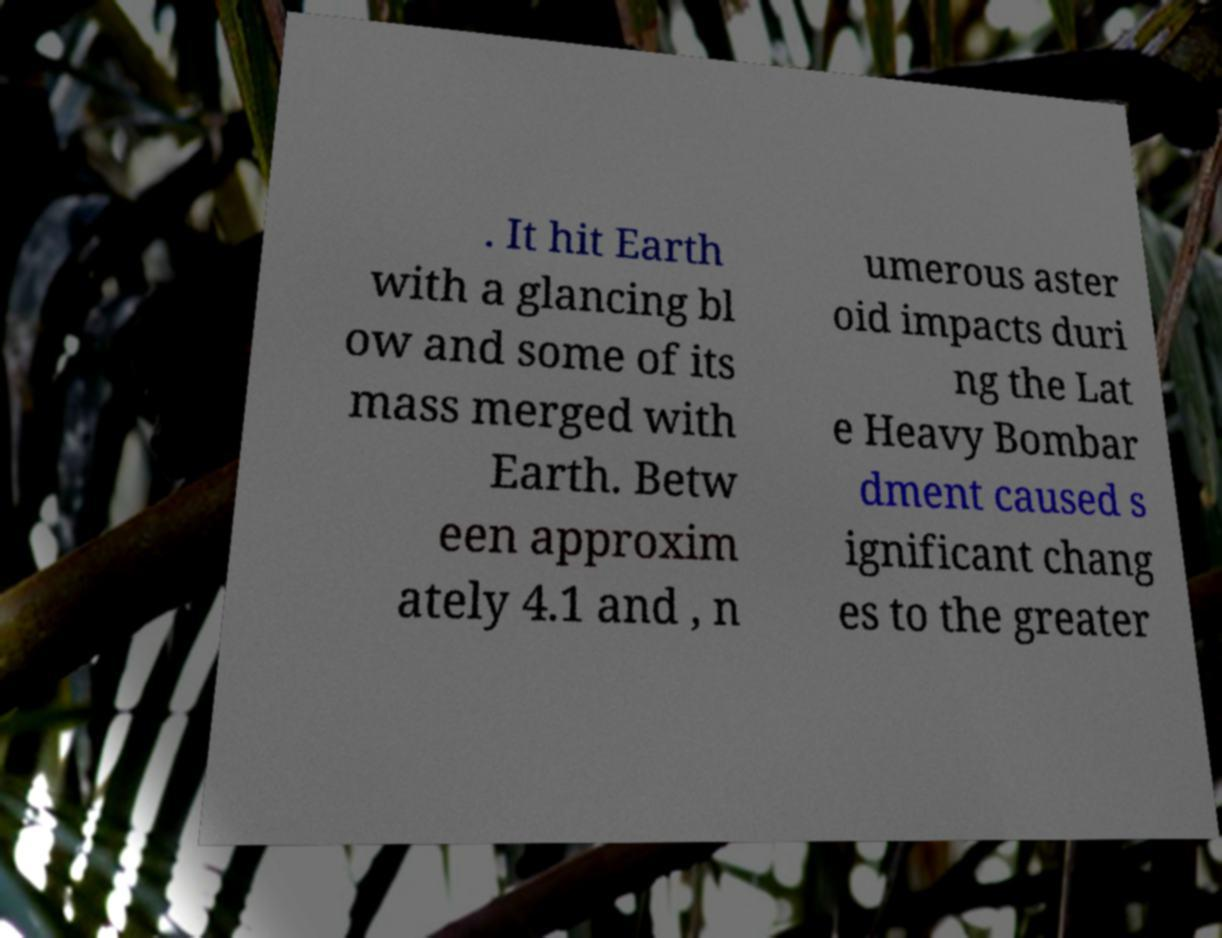For documentation purposes, I need the text within this image transcribed. Could you provide that? . It hit Earth with a glancing bl ow and some of its mass merged with Earth. Betw een approxim ately 4.1 and , n umerous aster oid impacts duri ng the Lat e Heavy Bombar dment caused s ignificant chang es to the greater 